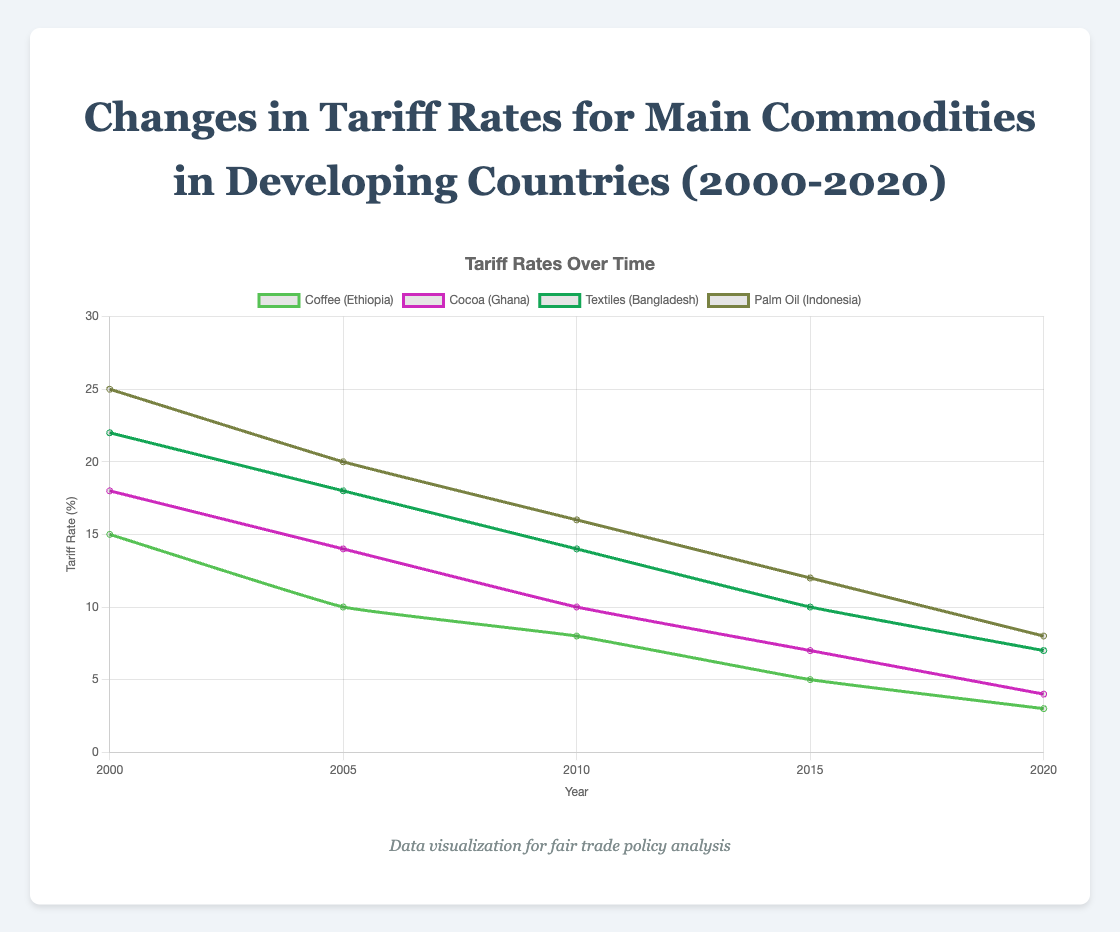What was the average tariff rate for cocoa in Ghana from 2000 to 2020? The tariff rates for cocoa in 2000, 2005, 2010, 2015, and 2020 are 18%, 14%, 10%, 7%, and 4%, respectively. To obtain the average, sum them up (18 + 14 + 10 + 7 + 4) = 53, then divide by the number of data points (5). So, 53 / 5 = 10.6%
Answer: 10.6% Which commodity had the highest initial tariff rate in the year 2000? By inspecting the tariff rates in 2000 for all commodities, Coffee (Ethiopia) had 15%, Cocoa (Ghana) 18%, Textiles (Bangladesh) 22%, and Palm Oil (Indonesia) 25%. Therefore, Palm Oil had the highest initial tariff rate
Answer: Palm Oil How did the tariff rate for textiles in Bangladesh change between 2005 and 2010? In 2005, the tariff rate for textiles in Bangladesh was 18%, and in 2010, it was 14%. The change is calculated by subtracting the later value from the earlier value: 18% - 14% = 4%. Hence, the tariff rate decreased by 4%
Answer: Decreased by 4% Compare the tariff rate trends for coffee in Ethiopia and palm oil in Indonesia from 2000 to 2020. Which commodity showed a greater reduction in tariff rates over this period? For coffee, the tariff rate decreased from 15% in 2000 to 3% in 2020, a reduction of 15% - 3% = 12%. For palm oil, it decreased from 25% in 2000 to 8% in 2020, a reduction of 25% - 8% = 17%. Hence, palm oil showed a greater reduction in tariff rates
Answer: Palm Oil By how much did the tariff rate for cocoa in Ghana decrease between 2000 and 2020? The tariff rate for cocoa in Ghana was 18% in 2000 and 4% in 2020. The decrease is computed by subtracting the later value from the earlier value: 18% - 4% = 14%
Answer: 14% Which year saw the largest decrease in tariff rates for coffee in Ethiopia and what was the amount of this decrease? By looking at the data over the years for coffee in Ethiopia, the changes are: 2000 to 2005 (15% to 10%, decrease of 5%), 2005 to 2010 (10% to 8%, decrease of 2%), 2010 to 2015 (8% to 5%, decrease of 3%), 2015 to 2020 (5% to 3%, decrease of 2%). The largest decrease occurred between 2000 and 2005 with a decrease of 5%
Answer: 2000 to 2005, 5% What is the visual trend observed for the tariff rates of all commodities from 2000 to 2020? The visual trend in the figure shows that the tariff rates for all the commodities (Coffee, Cocoa, Textiles, and Palm Oil) are decreasing over time between 2000 and 2020. All lines slope downward consistently
Answer: Decreasing trend Between which consecutive years did the tariff rate for textiles in Bangladesh show the smallest change? The changes are: 2000 to 2005 (22% to 18%, change of 4%), 2005 to 2010 (18% to 14%, change of 4%), 2010 to 2015 (14% to 10%, change of 4%), 2015 to 2020 (10% to 7%, change of 3%). The smallest change occurred between 2015 and 2020 with a change of 3%
Answer: 2015 to 2020 What is the total percentage decrease in tariff rates for palm oil in Indonesia from 2005 to 2020? The tariff rates for palm oil in Indonesia were 20% in 2005 and 8% in 2020. The total decrease is calculated by subtracting the later value from the earlier value: 20% - 8% = 12%
Answer: 12% By how much, on average, did the tariff rates decrease per year for cocoa in Ghana between 2000 and 2020? The tariff rate for cocoa decreased from 18% in 2000 to 4% in 2020, a total decrease of 18% - 4% = 14%. Over 20 years, the average annual decrease is 14% / 20 years = 0.7% per year
Answer: 0.7% per year 